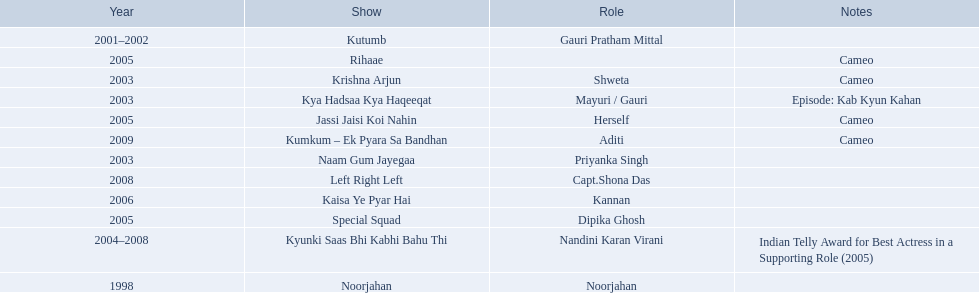What are all of the shows? Noorjahan, Kutumb, Krishna Arjun, Naam Gum Jayegaa, Kya Hadsaa Kya Haqeeqat, Kyunki Saas Bhi Kabhi Bahu Thi, Rihaae, Jassi Jaisi Koi Nahin, Special Squad, Kaisa Ye Pyar Hai, Left Right Left, Kumkum – Ek Pyara Sa Bandhan. When were they in production? 1998, 2001–2002, 2003, 2003, 2003, 2004–2008, 2005, 2005, 2005, 2006, 2008, 2009. And which show was he on for the longest time? Kyunki Saas Bhi Kabhi Bahu Thi. 